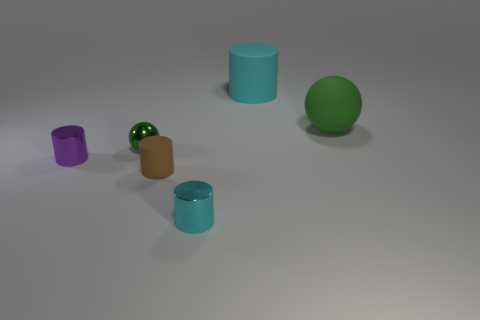There is a rubber cylinder that is right of the tiny cyan cylinder; is it the same color as the tiny metal ball?
Make the answer very short. No. Are there any other things that are the same shape as the small cyan metal object?
Make the answer very short. Yes. There is a cyan rubber thing that is behind the green metallic ball; are there any brown rubber things that are behind it?
Keep it short and to the point. No. Is the number of metallic balls that are in front of the tiny green metallic object less than the number of brown rubber things that are left of the small cyan metallic cylinder?
Keep it short and to the point. Yes. There is a green sphere that is to the left of the big thing left of the rubber thing to the right of the large cyan matte cylinder; what is its size?
Your answer should be compact. Small. There is a cyan cylinder in front of the green rubber thing; is its size the same as the large green thing?
Your answer should be very brief. No. Are there more matte cylinders than large red rubber balls?
Your answer should be compact. Yes. What is the material of the cyan object behind the green ball that is to the right of the rubber object left of the tiny cyan cylinder?
Offer a very short reply. Rubber. Does the tiny shiny ball have the same color as the large matte cylinder?
Make the answer very short. No. Is there another cylinder that has the same color as the large cylinder?
Your answer should be very brief. Yes. 